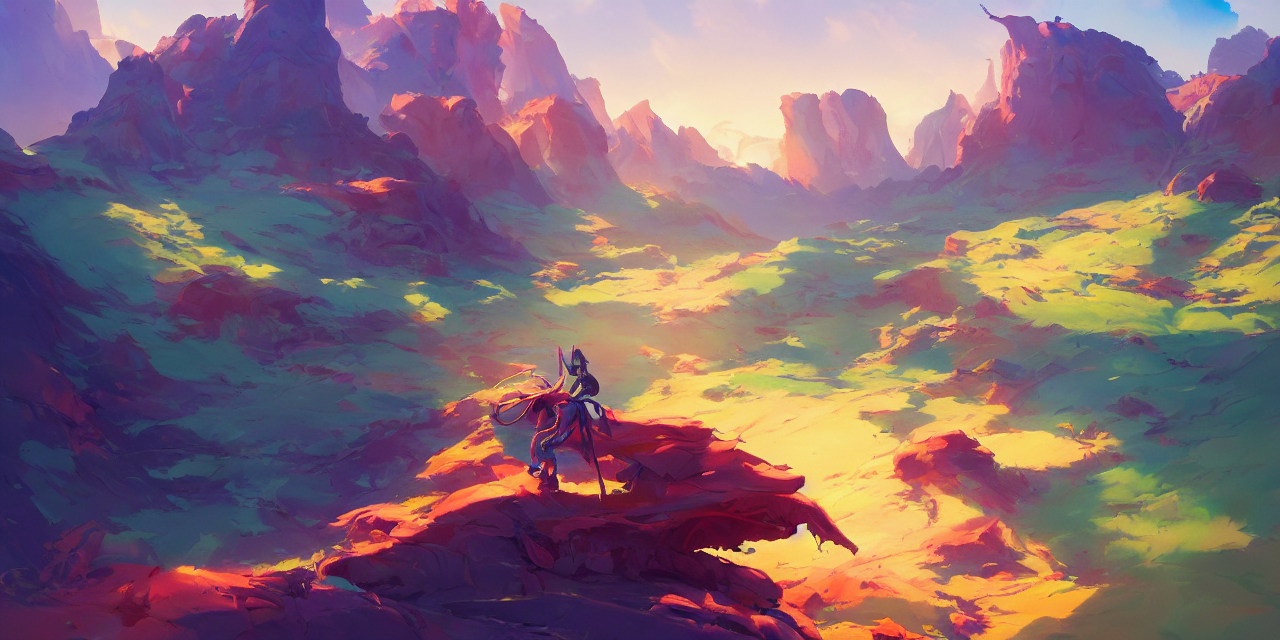Could you describe the character in the image? Certainly. The character appears to be a warrior or explorer type, garbed in armor, suggesting preparedness for conflict or challenge. The sleek silhouette and flow of the cape convey a blend of elegance and strength. 